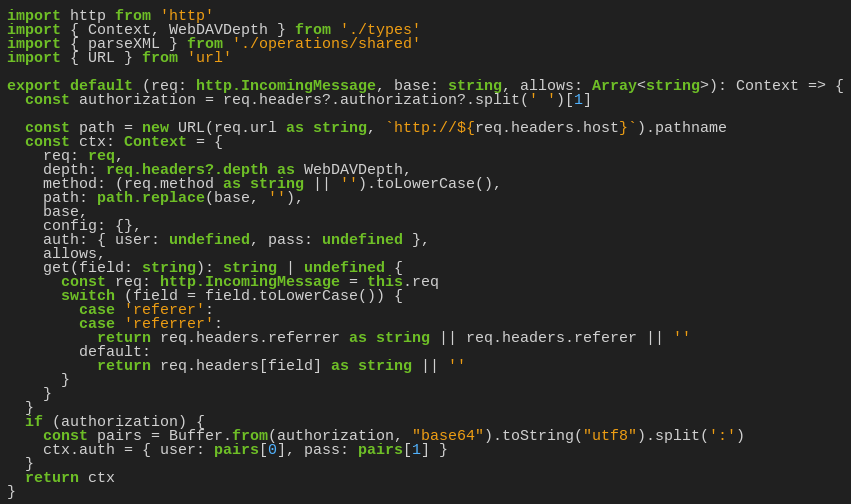Convert code to text. <code><loc_0><loc_0><loc_500><loc_500><_TypeScript_>import http from 'http'
import { Context, WebDAVDepth } from './types'
import { parseXML } from './operations/shared'
import { URL } from 'url'

export default (req: http.IncomingMessage, base: string, allows: Array<string>): Context => {
  const authorization = req.headers?.authorization?.split(' ')[1]

  const path = new URL(req.url as string, `http://${req.headers.host}`).pathname
  const ctx: Context = {
    req: req,
    depth: req.headers?.depth as WebDAVDepth,
    method: (req.method as string || '').toLowerCase(),
    path: path.replace(base, ''),
    base,
    config: {},
    auth: { user: undefined, pass: undefined },
    allows,
    get(field: string): string | undefined {
      const req: http.IncomingMessage = this.req
      switch (field = field.toLowerCase()) {
        case 'referer':
        case 'referrer':
          return req.headers.referrer as string || req.headers.referer || ''
        default:
          return req.headers[field] as string || ''
      }
    }
  }
  if (authorization) {
    const pairs = Buffer.from(authorization, "base64").toString("utf8").split(':')
    ctx.auth = { user: pairs[0], pass: pairs[1] }
  }
  return ctx
}</code> 